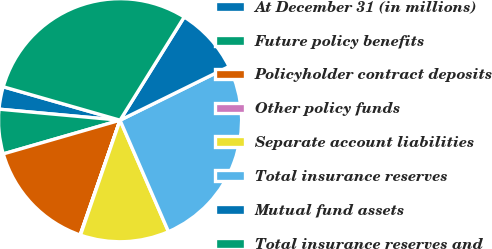<chart> <loc_0><loc_0><loc_500><loc_500><pie_chart><fcel>At December 31 (in millions)<fcel>Future policy benefits<fcel>Policyholder contract deposits<fcel>Other policy funds<fcel>Separate account liabilities<fcel>Total insurance reserves<fcel>Mutual fund assets<fcel>Total insurance reserves and<nl><fcel>2.99%<fcel>5.92%<fcel>15.2%<fcel>0.05%<fcel>11.8%<fcel>25.76%<fcel>8.86%<fcel>29.41%<nl></chart> 